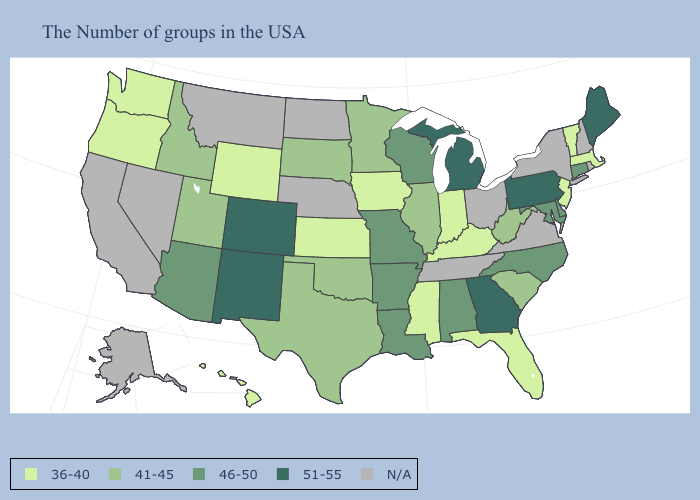Name the states that have a value in the range 36-40?
Write a very short answer. Massachusetts, Vermont, New Jersey, Florida, Kentucky, Indiana, Mississippi, Iowa, Kansas, Wyoming, Washington, Oregon, Hawaii. What is the lowest value in the USA?
Keep it brief. 36-40. What is the lowest value in states that border Georgia?
Short answer required. 36-40. What is the lowest value in states that border North Carolina?
Write a very short answer. 41-45. Does the first symbol in the legend represent the smallest category?
Give a very brief answer. Yes. What is the highest value in the West ?
Short answer required. 51-55. Name the states that have a value in the range 51-55?
Give a very brief answer. Maine, Pennsylvania, Georgia, Michigan, Colorado, New Mexico. What is the lowest value in states that border Montana?
Concise answer only. 36-40. Does the first symbol in the legend represent the smallest category?
Write a very short answer. Yes. Name the states that have a value in the range 46-50?
Concise answer only. Connecticut, Delaware, Maryland, North Carolina, Alabama, Wisconsin, Louisiana, Missouri, Arkansas, Arizona. What is the highest value in the USA?
Give a very brief answer. 51-55. What is the value of North Dakota?
Give a very brief answer. N/A. What is the value of New Mexico?
Be succinct. 51-55. What is the value of Nebraska?
Be succinct. N/A. What is the highest value in states that border South Dakota?
Short answer required. 41-45. 